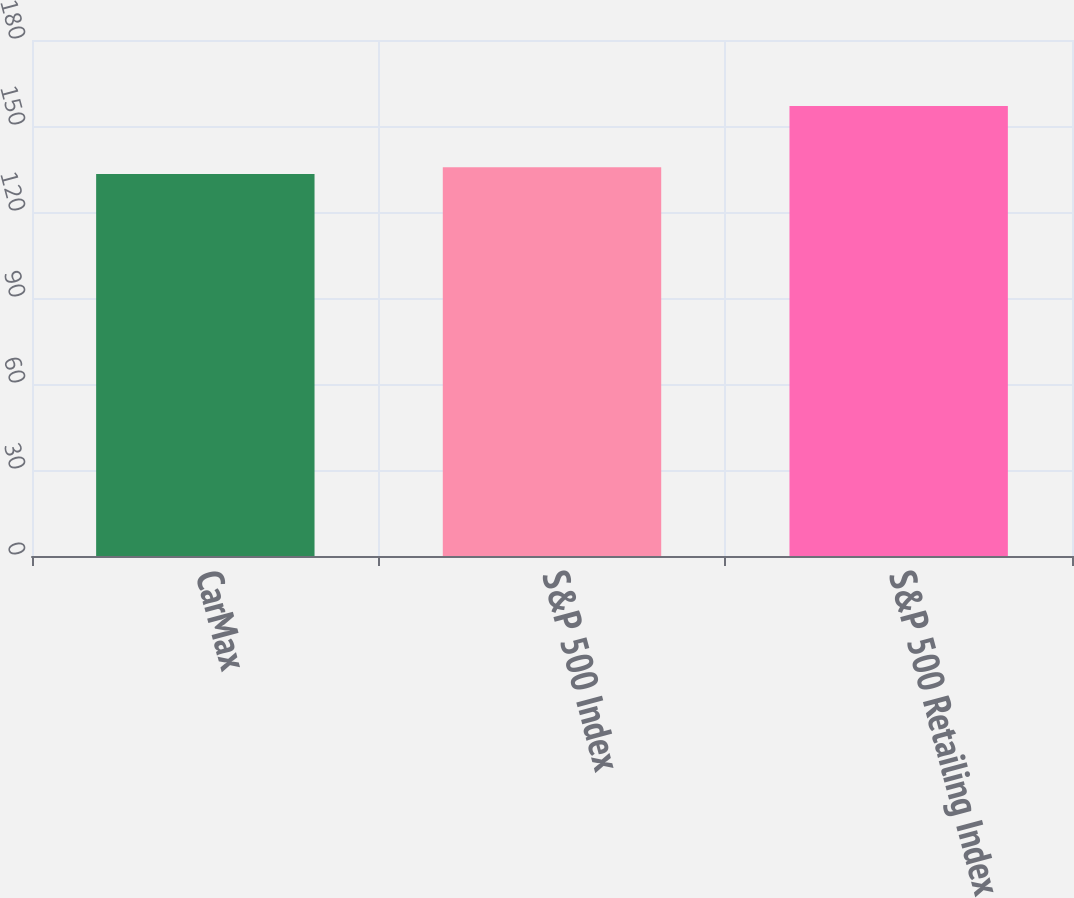Convert chart. <chart><loc_0><loc_0><loc_500><loc_500><bar_chart><fcel>CarMax<fcel>S&P 500 Index<fcel>S&P 500 Retailing Index<nl><fcel>133.26<fcel>135.64<fcel>157.02<nl></chart> 